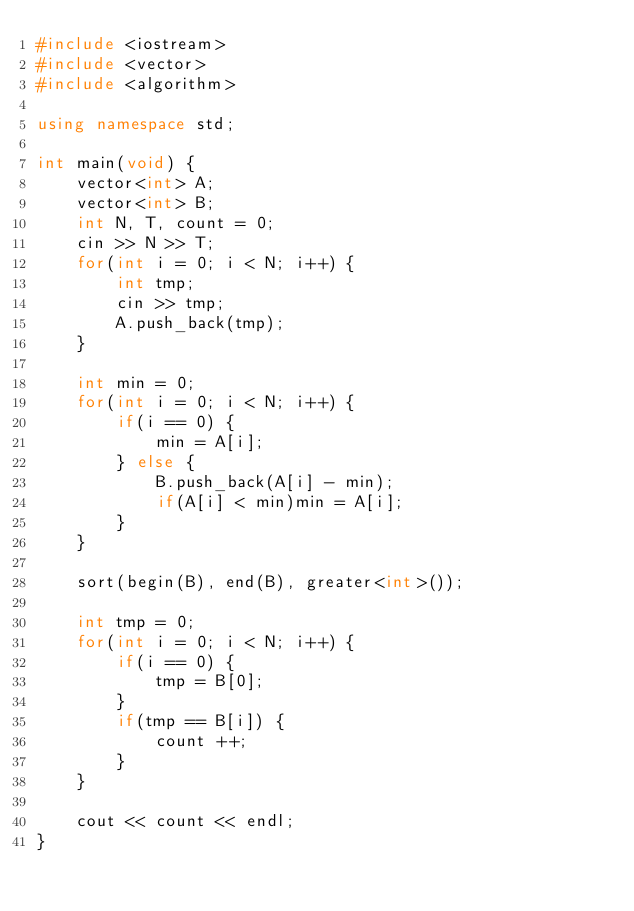Convert code to text. <code><loc_0><loc_0><loc_500><loc_500><_C++_>#include <iostream>
#include <vector>
#include <algorithm>

using namespace std;

int main(void) {
	vector<int> A;
	vector<int> B;
	int N, T, count = 0;
	cin >> N >> T;
	for(int i = 0; i < N; i++) {
		int tmp;
		cin >> tmp;
		A.push_back(tmp);
	}

	int min = 0;
	for(int i = 0; i < N; i++) {
		if(i == 0) {
			min = A[i];
		} else {
			B.push_back(A[i] - min);
			if(A[i] < min)min = A[i];
		}
	}

	sort(begin(B), end(B), greater<int>());

	int tmp = 0;
	for(int i = 0; i < N; i++) {
		if(i == 0) {
			tmp = B[0];
		}
		if(tmp == B[i]) {
			count ++;
		}
	}

	cout << count << endl;
}
</code> 